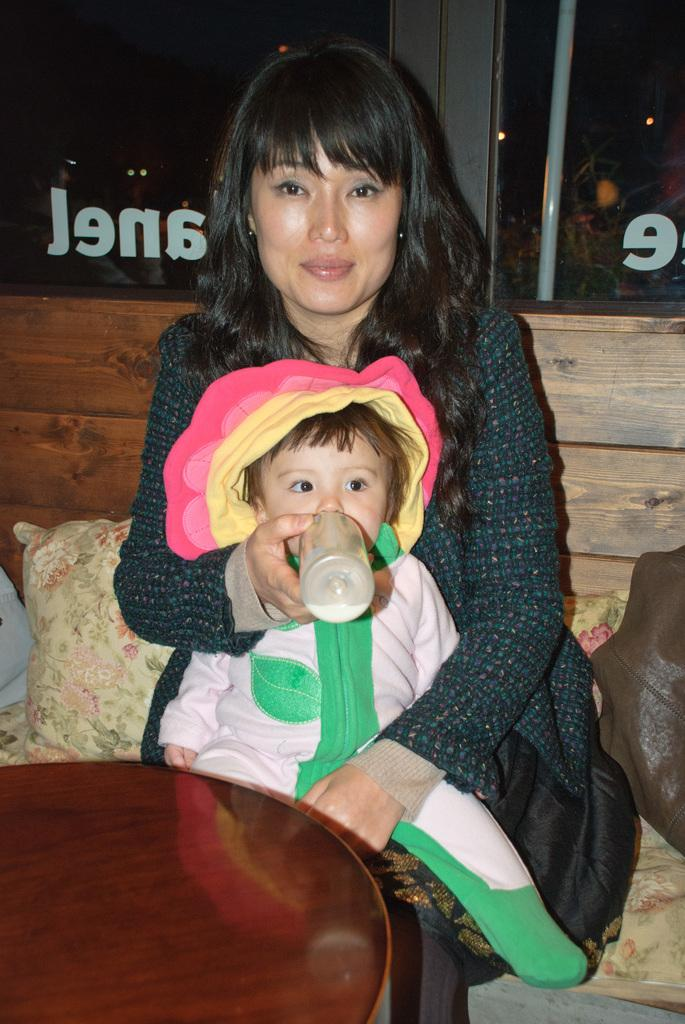Who is present in the image? There is a woman in the image. What is the woman doing in the image? The woman is sitting and holding a milk bottle in her hand. What is the woman's facial expression in the image? The woman is smiling in the image. Who is with the woman in the image? There is a baby with the woman in the image. What is in front of the woman in the image? There is a table in front of the woman in the image. What is on the table in the image? There are pillows on the table in the image. What can be seen in the background of the image? There is a wall visible in the image. What type of belief does the woman have in the image? There is no information about the woman's beliefs in the image. Can you see any birds in the image? There are no birds visible in the image. 